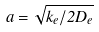<formula> <loc_0><loc_0><loc_500><loc_500>a = \sqrt { k _ { e } / 2 D _ { e } }</formula> 